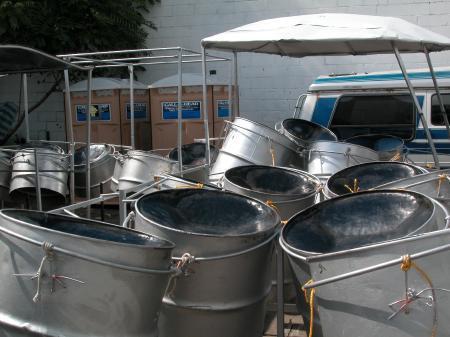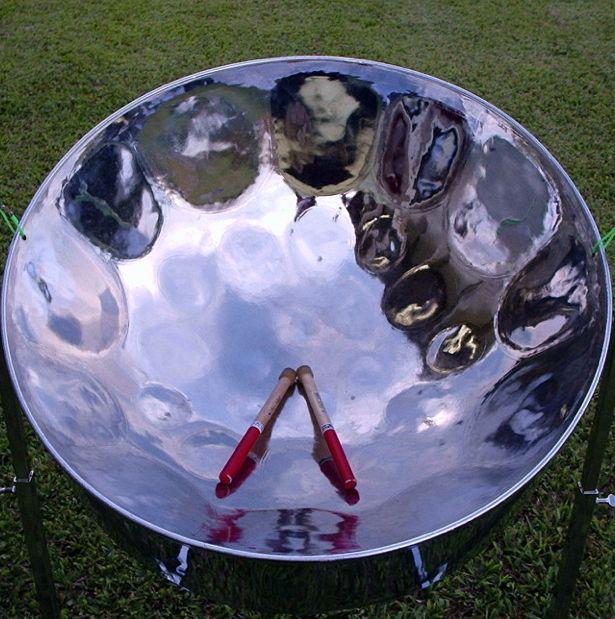The first image is the image on the left, the second image is the image on the right. Evaluate the accuracy of this statement regarding the images: "The left image shows musicians standing behind no more than four steel drums, and exactly one musician is wearing a fedora hat.". Is it true? Answer yes or no. No. The first image is the image on the left, the second image is the image on the right. Given the left and right images, does the statement "There is at least one person wearing a hat." hold true? Answer yes or no. No. 